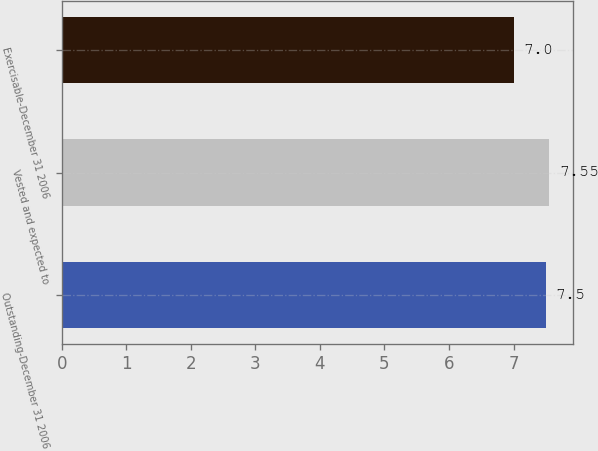Convert chart. <chart><loc_0><loc_0><loc_500><loc_500><bar_chart><fcel>Outstanding-December 31 2006<fcel>Vested and expected to<fcel>Exercisable-December 31 2006<nl><fcel>7.5<fcel>7.55<fcel>7<nl></chart> 